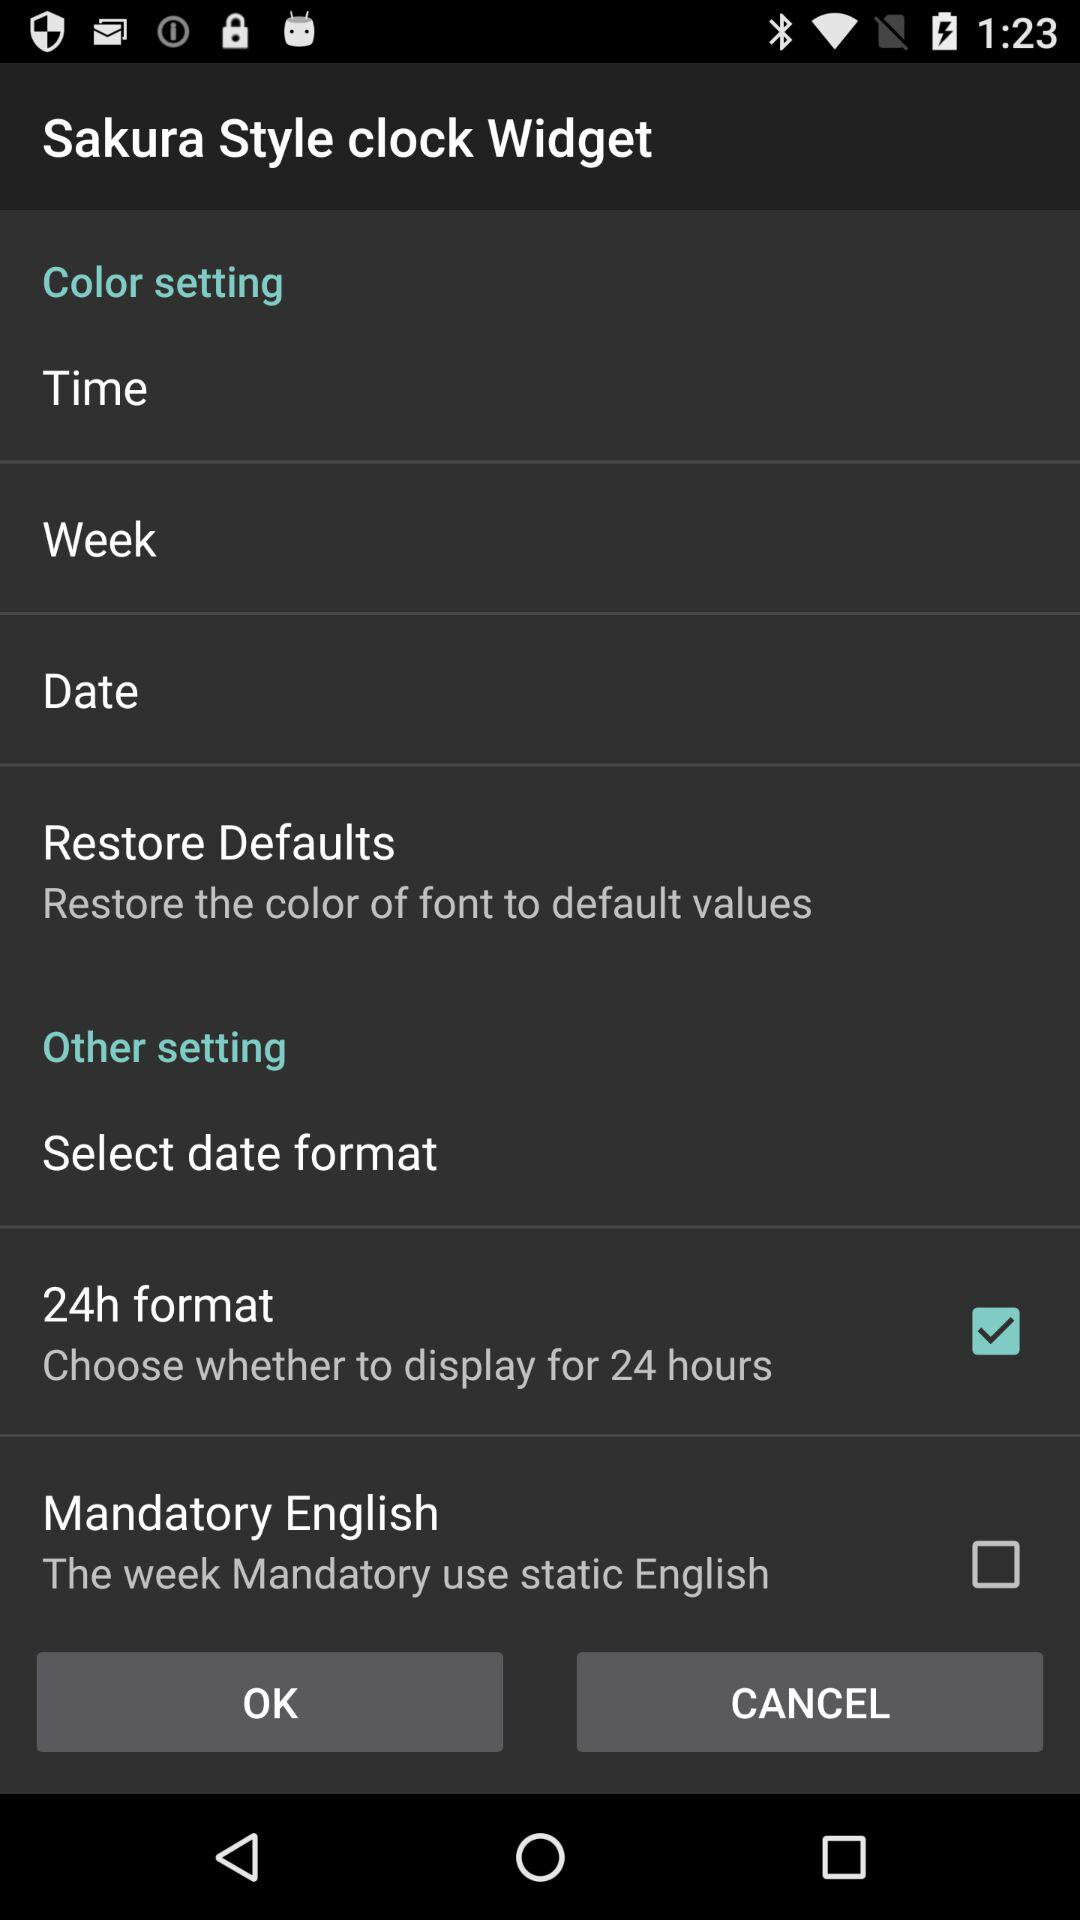What's the status of "24h format"? The status is "on". 